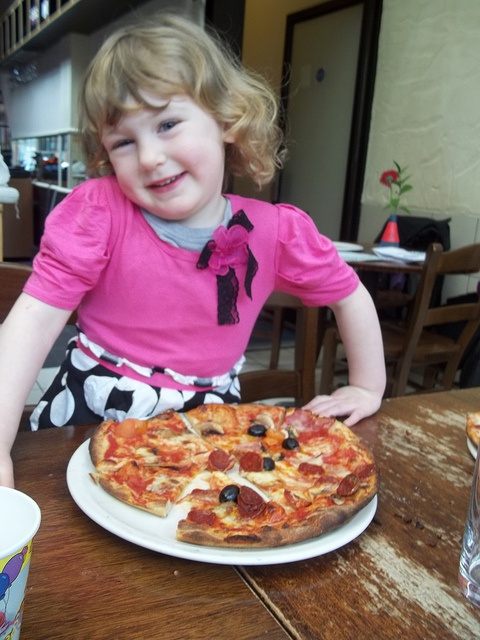Describe the objects in this image and their specific colors. I can see people in black, magenta, lightgray, darkgray, and gray tones, dining table in black, maroon, and gray tones, pizza in black, tan, brown, and salmon tones, chair in black and gray tones, and chair in black, maroon, and gray tones in this image. 